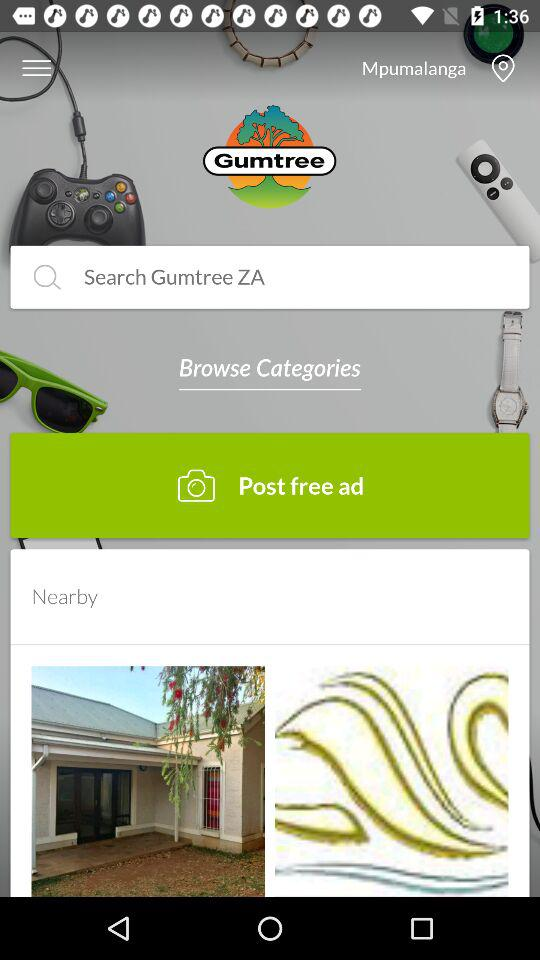What is the given location? The given location is Mpumalanga. 